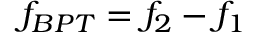<formula> <loc_0><loc_0><loc_500><loc_500>f _ { B P T } = f _ { 2 } - f _ { 1 }</formula> 